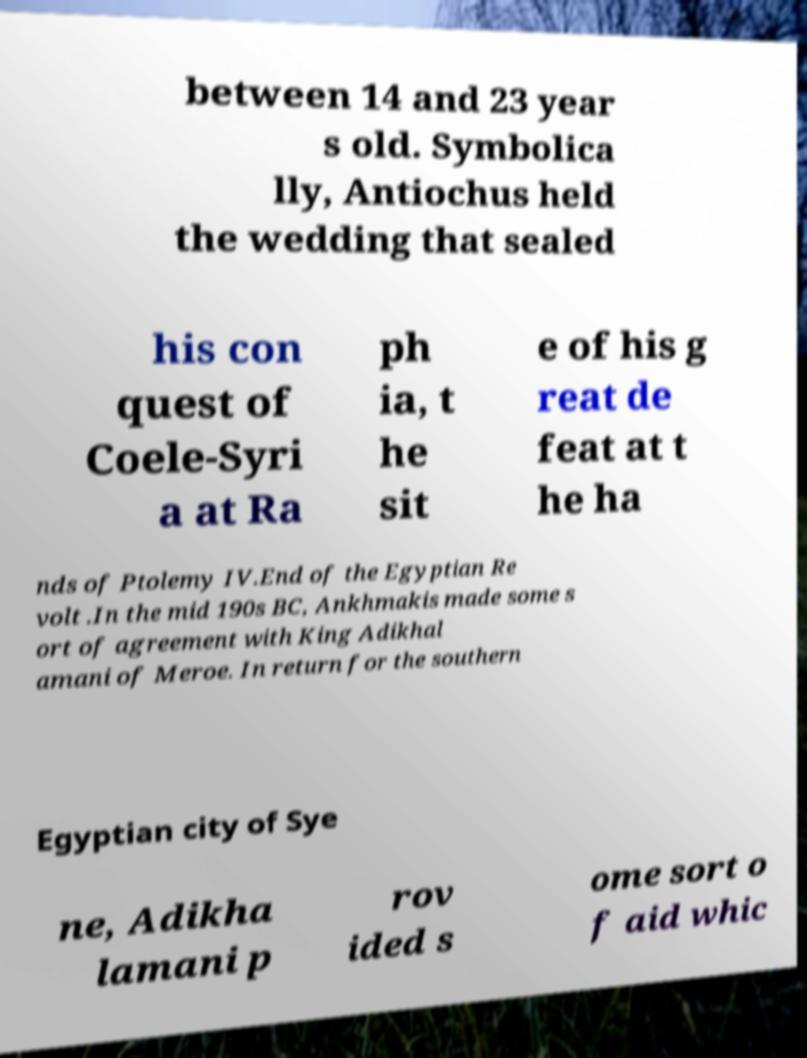Please identify and transcribe the text found in this image. between 14 and 23 year s old. Symbolica lly, Antiochus held the wedding that sealed his con quest of Coele-Syri a at Ra ph ia, t he sit e of his g reat de feat at t he ha nds of Ptolemy IV.End of the Egyptian Re volt .In the mid 190s BC, Ankhmakis made some s ort of agreement with King Adikhal amani of Meroe. In return for the southern Egyptian city of Sye ne, Adikha lamani p rov ided s ome sort o f aid whic 